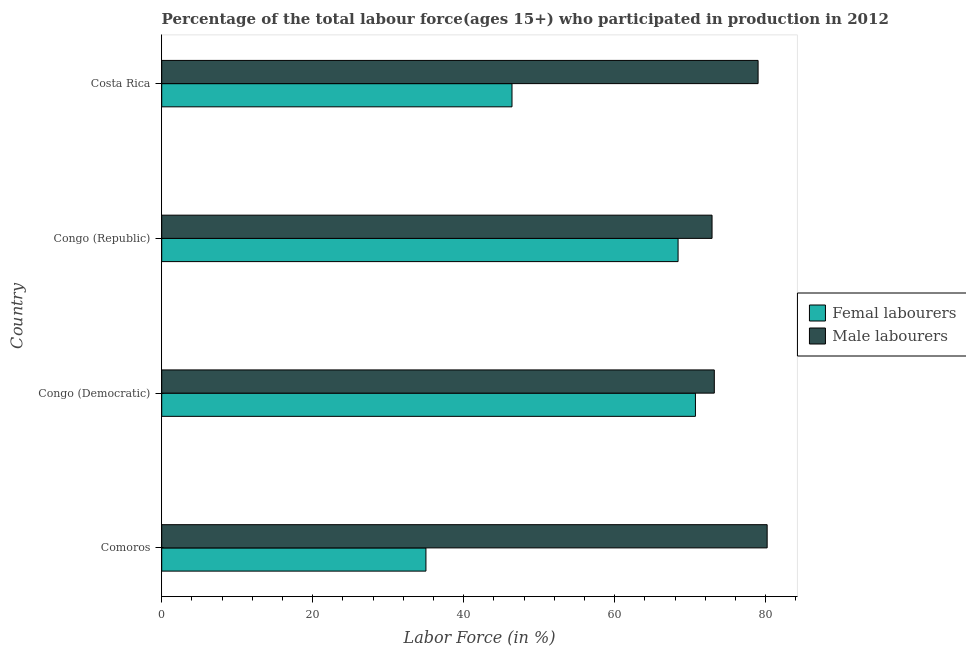How many bars are there on the 3rd tick from the top?
Your answer should be compact. 2. What is the label of the 4th group of bars from the top?
Your answer should be very brief. Comoros. In how many cases, is the number of bars for a given country not equal to the number of legend labels?
Make the answer very short. 0. What is the percentage of female labor force in Comoros?
Give a very brief answer. 35. Across all countries, what is the maximum percentage of male labour force?
Provide a short and direct response. 80.2. Across all countries, what is the minimum percentage of male labour force?
Give a very brief answer. 72.9. In which country was the percentage of female labor force maximum?
Keep it short and to the point. Congo (Democratic). In which country was the percentage of female labor force minimum?
Offer a terse response. Comoros. What is the total percentage of female labor force in the graph?
Your answer should be compact. 220.5. What is the difference between the percentage of male labour force in Comoros and that in Congo (Democratic)?
Your answer should be very brief. 7. What is the difference between the percentage of male labour force in Comoros and the percentage of female labor force in Congo (Republic)?
Your response must be concise. 11.8. What is the average percentage of female labor force per country?
Your answer should be compact. 55.12. What is the difference between the percentage of male labour force and percentage of female labor force in Costa Rica?
Offer a terse response. 32.6. In how many countries, is the percentage of female labor force greater than 24 %?
Give a very brief answer. 4. What is the ratio of the percentage of male labour force in Comoros to that in Congo (Democratic)?
Make the answer very short. 1.1. Is the difference between the percentage of male labour force in Comoros and Congo (Republic) greater than the difference between the percentage of female labor force in Comoros and Congo (Republic)?
Offer a very short reply. Yes. What is the difference between the highest and the second highest percentage of male labour force?
Ensure brevity in your answer.  1.2. What is the difference between the highest and the lowest percentage of female labor force?
Offer a terse response. 35.7. What does the 1st bar from the top in Congo (Democratic) represents?
Make the answer very short. Male labourers. What does the 2nd bar from the bottom in Costa Rica represents?
Make the answer very short. Male labourers. How many bars are there?
Your response must be concise. 8. Are all the bars in the graph horizontal?
Provide a succinct answer. Yes. How many countries are there in the graph?
Your answer should be compact. 4. What is the difference between two consecutive major ticks on the X-axis?
Offer a very short reply. 20. Does the graph contain grids?
Your answer should be very brief. No. Where does the legend appear in the graph?
Ensure brevity in your answer.  Center right. How many legend labels are there?
Ensure brevity in your answer.  2. How are the legend labels stacked?
Your answer should be very brief. Vertical. What is the title of the graph?
Provide a short and direct response. Percentage of the total labour force(ages 15+) who participated in production in 2012. Does "Urban" appear as one of the legend labels in the graph?
Offer a very short reply. No. What is the label or title of the X-axis?
Provide a short and direct response. Labor Force (in %). What is the label or title of the Y-axis?
Offer a very short reply. Country. What is the Labor Force (in %) in Femal labourers in Comoros?
Offer a very short reply. 35. What is the Labor Force (in %) of Male labourers in Comoros?
Your answer should be compact. 80.2. What is the Labor Force (in %) of Femal labourers in Congo (Democratic)?
Keep it short and to the point. 70.7. What is the Labor Force (in %) of Male labourers in Congo (Democratic)?
Ensure brevity in your answer.  73.2. What is the Labor Force (in %) in Femal labourers in Congo (Republic)?
Your answer should be very brief. 68.4. What is the Labor Force (in %) in Male labourers in Congo (Republic)?
Provide a short and direct response. 72.9. What is the Labor Force (in %) in Femal labourers in Costa Rica?
Offer a very short reply. 46.4. What is the Labor Force (in %) in Male labourers in Costa Rica?
Make the answer very short. 79. Across all countries, what is the maximum Labor Force (in %) in Femal labourers?
Provide a succinct answer. 70.7. Across all countries, what is the maximum Labor Force (in %) in Male labourers?
Keep it short and to the point. 80.2. Across all countries, what is the minimum Labor Force (in %) of Femal labourers?
Ensure brevity in your answer.  35. Across all countries, what is the minimum Labor Force (in %) of Male labourers?
Ensure brevity in your answer.  72.9. What is the total Labor Force (in %) in Femal labourers in the graph?
Offer a terse response. 220.5. What is the total Labor Force (in %) of Male labourers in the graph?
Provide a short and direct response. 305.3. What is the difference between the Labor Force (in %) in Femal labourers in Comoros and that in Congo (Democratic)?
Offer a very short reply. -35.7. What is the difference between the Labor Force (in %) of Femal labourers in Comoros and that in Congo (Republic)?
Your answer should be compact. -33.4. What is the difference between the Labor Force (in %) in Femal labourers in Comoros and that in Costa Rica?
Your answer should be very brief. -11.4. What is the difference between the Labor Force (in %) in Male labourers in Comoros and that in Costa Rica?
Keep it short and to the point. 1.2. What is the difference between the Labor Force (in %) in Femal labourers in Congo (Democratic) and that in Congo (Republic)?
Your answer should be very brief. 2.3. What is the difference between the Labor Force (in %) of Male labourers in Congo (Democratic) and that in Congo (Republic)?
Your answer should be compact. 0.3. What is the difference between the Labor Force (in %) of Femal labourers in Congo (Democratic) and that in Costa Rica?
Give a very brief answer. 24.3. What is the difference between the Labor Force (in %) of Male labourers in Congo (Democratic) and that in Costa Rica?
Your response must be concise. -5.8. What is the difference between the Labor Force (in %) in Femal labourers in Comoros and the Labor Force (in %) in Male labourers in Congo (Democratic)?
Your answer should be very brief. -38.2. What is the difference between the Labor Force (in %) in Femal labourers in Comoros and the Labor Force (in %) in Male labourers in Congo (Republic)?
Ensure brevity in your answer.  -37.9. What is the difference between the Labor Force (in %) in Femal labourers in Comoros and the Labor Force (in %) in Male labourers in Costa Rica?
Give a very brief answer. -44. What is the difference between the Labor Force (in %) in Femal labourers in Congo (Democratic) and the Labor Force (in %) in Male labourers in Congo (Republic)?
Your response must be concise. -2.2. What is the difference between the Labor Force (in %) in Femal labourers in Congo (Democratic) and the Labor Force (in %) in Male labourers in Costa Rica?
Keep it short and to the point. -8.3. What is the average Labor Force (in %) in Femal labourers per country?
Give a very brief answer. 55.12. What is the average Labor Force (in %) in Male labourers per country?
Provide a succinct answer. 76.33. What is the difference between the Labor Force (in %) of Femal labourers and Labor Force (in %) of Male labourers in Comoros?
Provide a succinct answer. -45.2. What is the difference between the Labor Force (in %) of Femal labourers and Labor Force (in %) of Male labourers in Congo (Democratic)?
Make the answer very short. -2.5. What is the difference between the Labor Force (in %) in Femal labourers and Labor Force (in %) in Male labourers in Costa Rica?
Provide a succinct answer. -32.6. What is the ratio of the Labor Force (in %) in Femal labourers in Comoros to that in Congo (Democratic)?
Your answer should be very brief. 0.49. What is the ratio of the Labor Force (in %) in Male labourers in Comoros to that in Congo (Democratic)?
Provide a succinct answer. 1.1. What is the ratio of the Labor Force (in %) in Femal labourers in Comoros to that in Congo (Republic)?
Your response must be concise. 0.51. What is the ratio of the Labor Force (in %) in Male labourers in Comoros to that in Congo (Republic)?
Give a very brief answer. 1.1. What is the ratio of the Labor Force (in %) in Femal labourers in Comoros to that in Costa Rica?
Ensure brevity in your answer.  0.75. What is the ratio of the Labor Force (in %) of Male labourers in Comoros to that in Costa Rica?
Make the answer very short. 1.02. What is the ratio of the Labor Force (in %) of Femal labourers in Congo (Democratic) to that in Congo (Republic)?
Your answer should be compact. 1.03. What is the ratio of the Labor Force (in %) in Femal labourers in Congo (Democratic) to that in Costa Rica?
Provide a short and direct response. 1.52. What is the ratio of the Labor Force (in %) of Male labourers in Congo (Democratic) to that in Costa Rica?
Offer a very short reply. 0.93. What is the ratio of the Labor Force (in %) of Femal labourers in Congo (Republic) to that in Costa Rica?
Ensure brevity in your answer.  1.47. What is the ratio of the Labor Force (in %) of Male labourers in Congo (Republic) to that in Costa Rica?
Provide a succinct answer. 0.92. What is the difference between the highest and the second highest Labor Force (in %) in Femal labourers?
Provide a succinct answer. 2.3. What is the difference between the highest and the second highest Labor Force (in %) of Male labourers?
Your answer should be compact. 1.2. What is the difference between the highest and the lowest Labor Force (in %) of Femal labourers?
Your answer should be very brief. 35.7. What is the difference between the highest and the lowest Labor Force (in %) in Male labourers?
Offer a terse response. 7.3. 